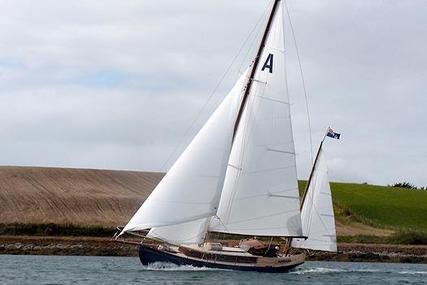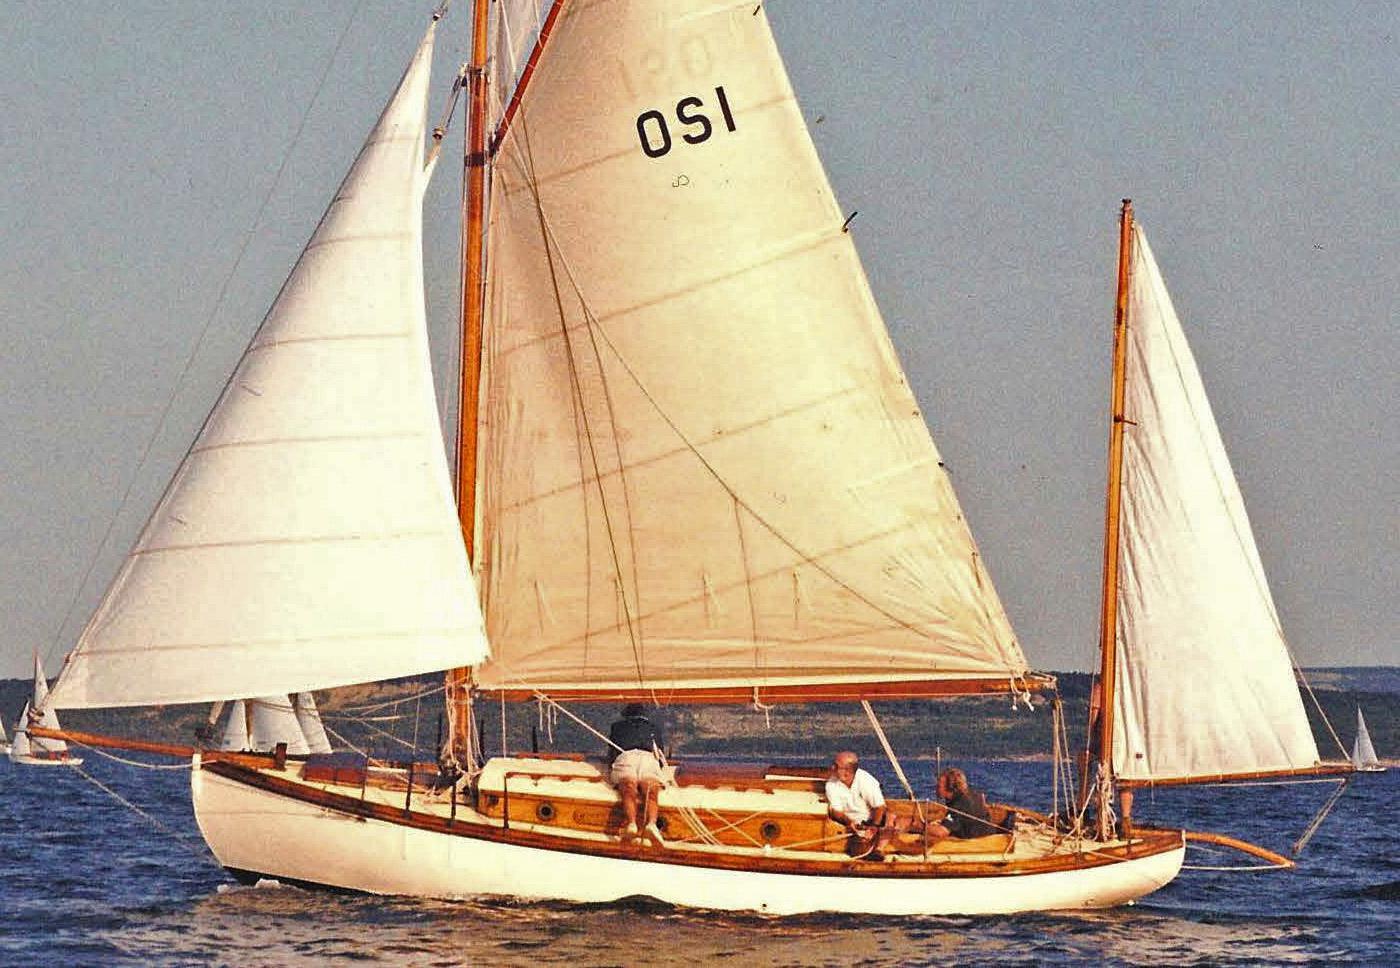The first image is the image on the left, the second image is the image on the right. For the images displayed, is the sentence "Both of the boats have all their sails up." factually correct? Answer yes or no. Yes. 